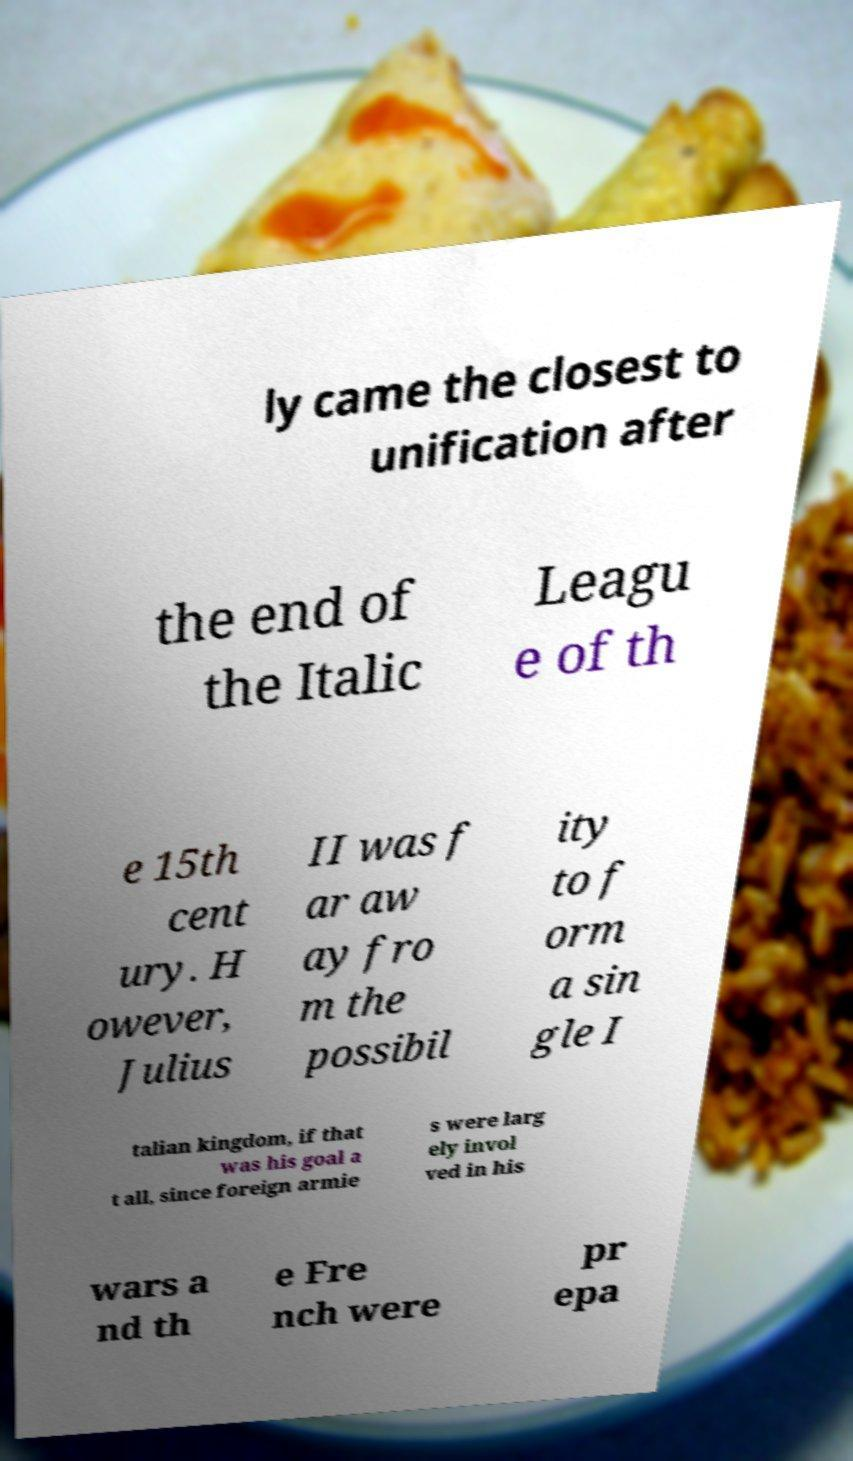Can you accurately transcribe the text from the provided image for me? ly came the closest to unification after the end of the Italic Leagu e of th e 15th cent ury. H owever, Julius II was f ar aw ay fro m the possibil ity to f orm a sin gle I talian kingdom, if that was his goal a t all, since foreign armie s were larg ely invol ved in his wars a nd th e Fre nch were pr epa 